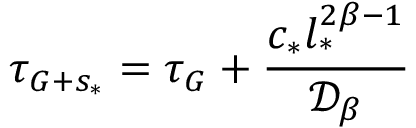<formula> <loc_0><loc_0><loc_500><loc_500>\tau _ { G + s _ { * } } = \tau _ { G } + \frac { c _ { * } l _ { * } ^ { 2 \beta - 1 } } { \mathcal { D } _ { \beta } }</formula> 